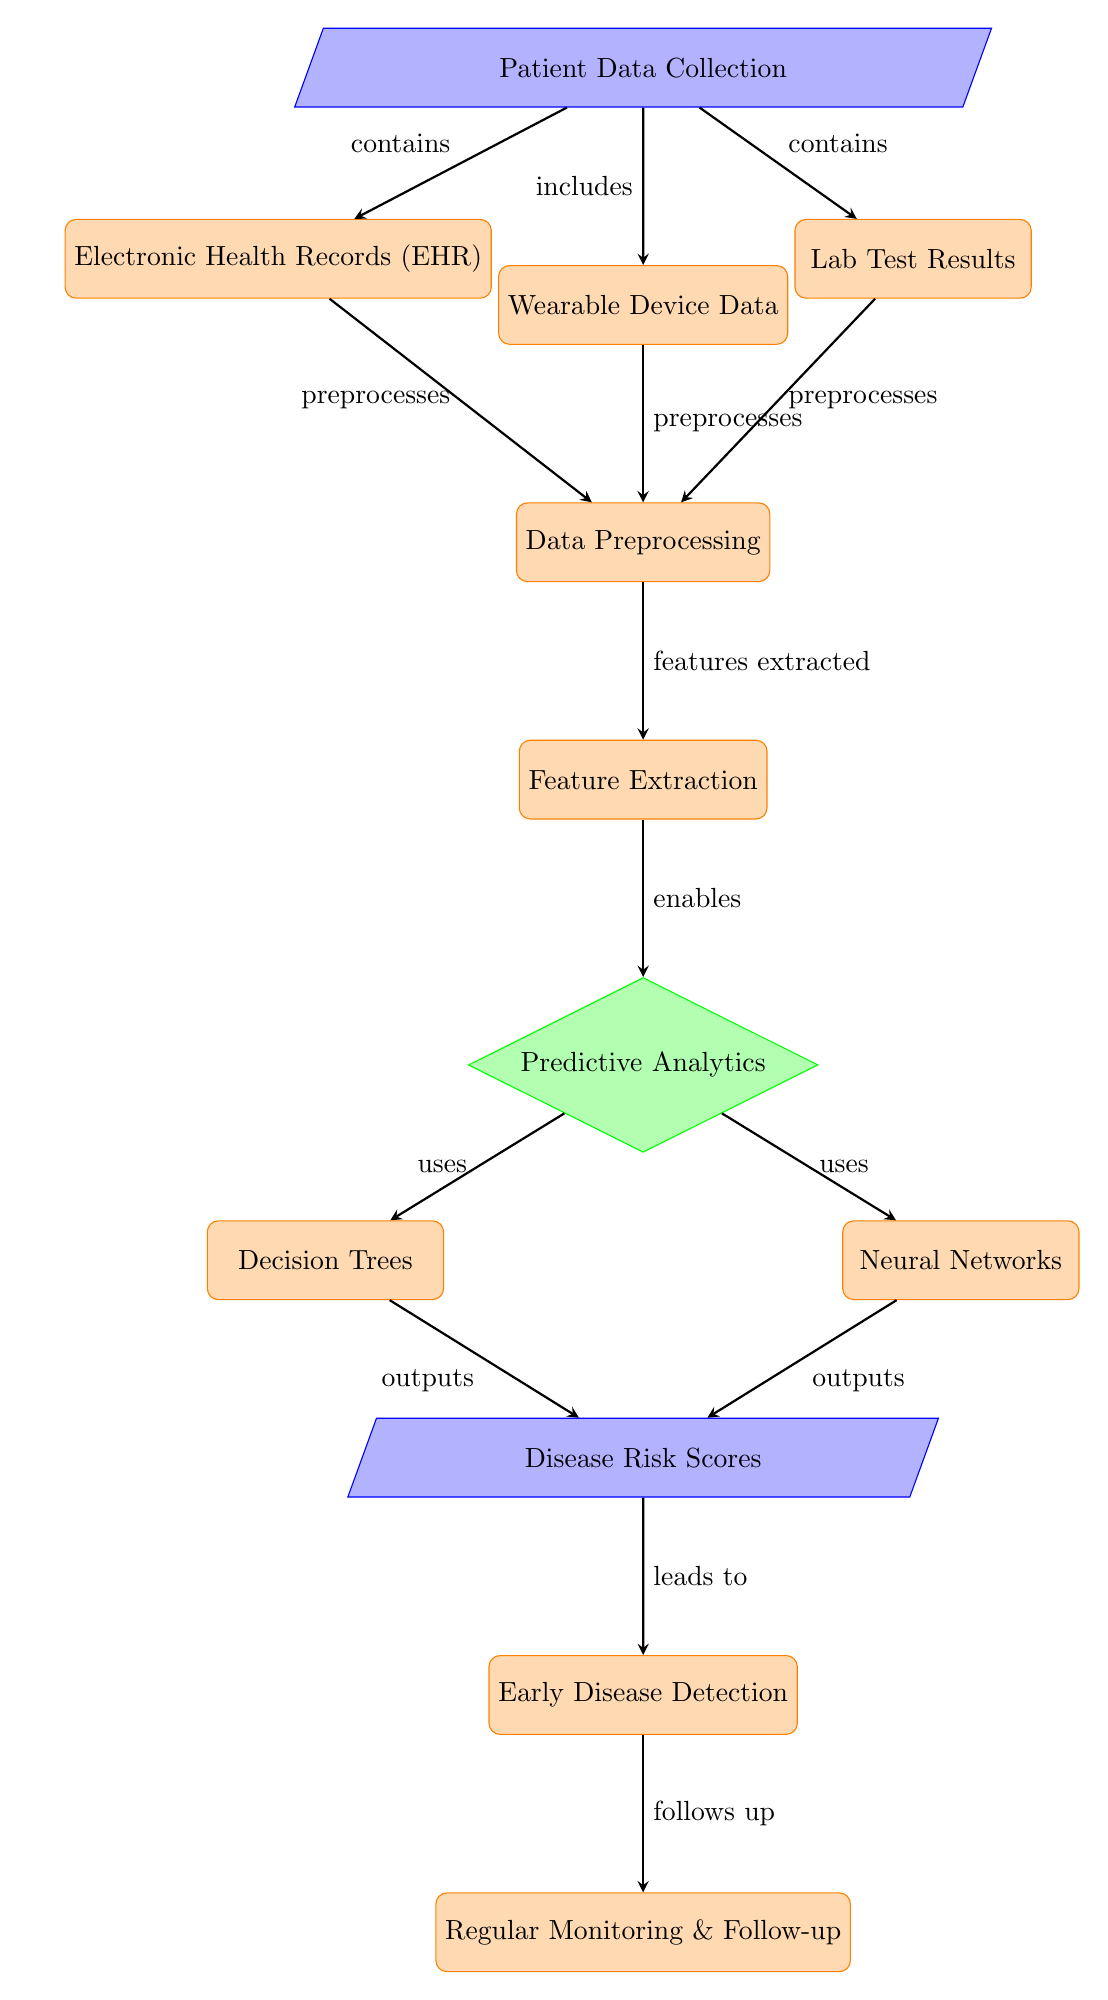What is the starting point of the diagram? The diagram starts with the node labeled "Patient Data Collection," which indicates the initial stage of data input for the process.
Answer: Patient Data Collection How many processes are identified in the diagram? Counting the nodes categorized as processes, we find a total of six: Electronic Health Records, Wearable Device Data, Lab Test Results, Data Preprocessing, Feature Extraction, and Early Disease Detection.
Answer: Six What method is used for predictive analytics in this diagram? The diagram specifically mentions two methods utilized for predictive analytics: Decision Trees and Neural Networks, which are both shown as outputs from the Predictive Analytics node.
Answer: Decision Trees and Neural Networks What follows the output of the Disease Risk Scores? According to the diagram, the output of Disease Risk Scores leads directly to the node labeled "Early Disease Detection," indicating the next step in the process.
Answer: Early Disease Detection How do data from Electronic Health Records, Wearable Device Data, and Lab Test Results relate in the preprocessing stage? All three data sources are shown to preprocess into the Data Preprocessing step before further analysis, indicating that they contribute equally to preparing the data for feature extraction.
Answer: Preprocesses Which two nodes provide outputs to the Disease Risk Scores? The outputs to the Disease Risk Scores come from two nodes: Decision Trees and Neural Networks, both of which are processes directly contributing to the risk scoring.
Answer: Decision Trees and Neural Networks How many types of data are aggregated in Patient Data Collection? The diagram shows three types of data involved in the Patient Data Collection: Electronic Health Records, Wearable Device Data, and Lab Test Results, all of which are collected as inputs.
Answer: Three What is the role of Feature Extraction in the context of this diagram? Feature Extraction acts as a crucial step allowing data from the preprocessing phase to be transformed into usable features that will be utilized in the Predictive Analytics step, which is essential for effective disease detection.
Answer: Enables Predictive Analytics 